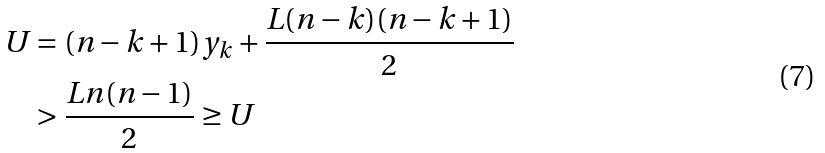<formula> <loc_0><loc_0><loc_500><loc_500>U & = ( n - k + 1 ) y _ { k } + \frac { L ( n - k ) ( n - k + 1 ) } { 2 } \\ & > \frac { L n ( n - 1 ) } { 2 } \geq U</formula> 